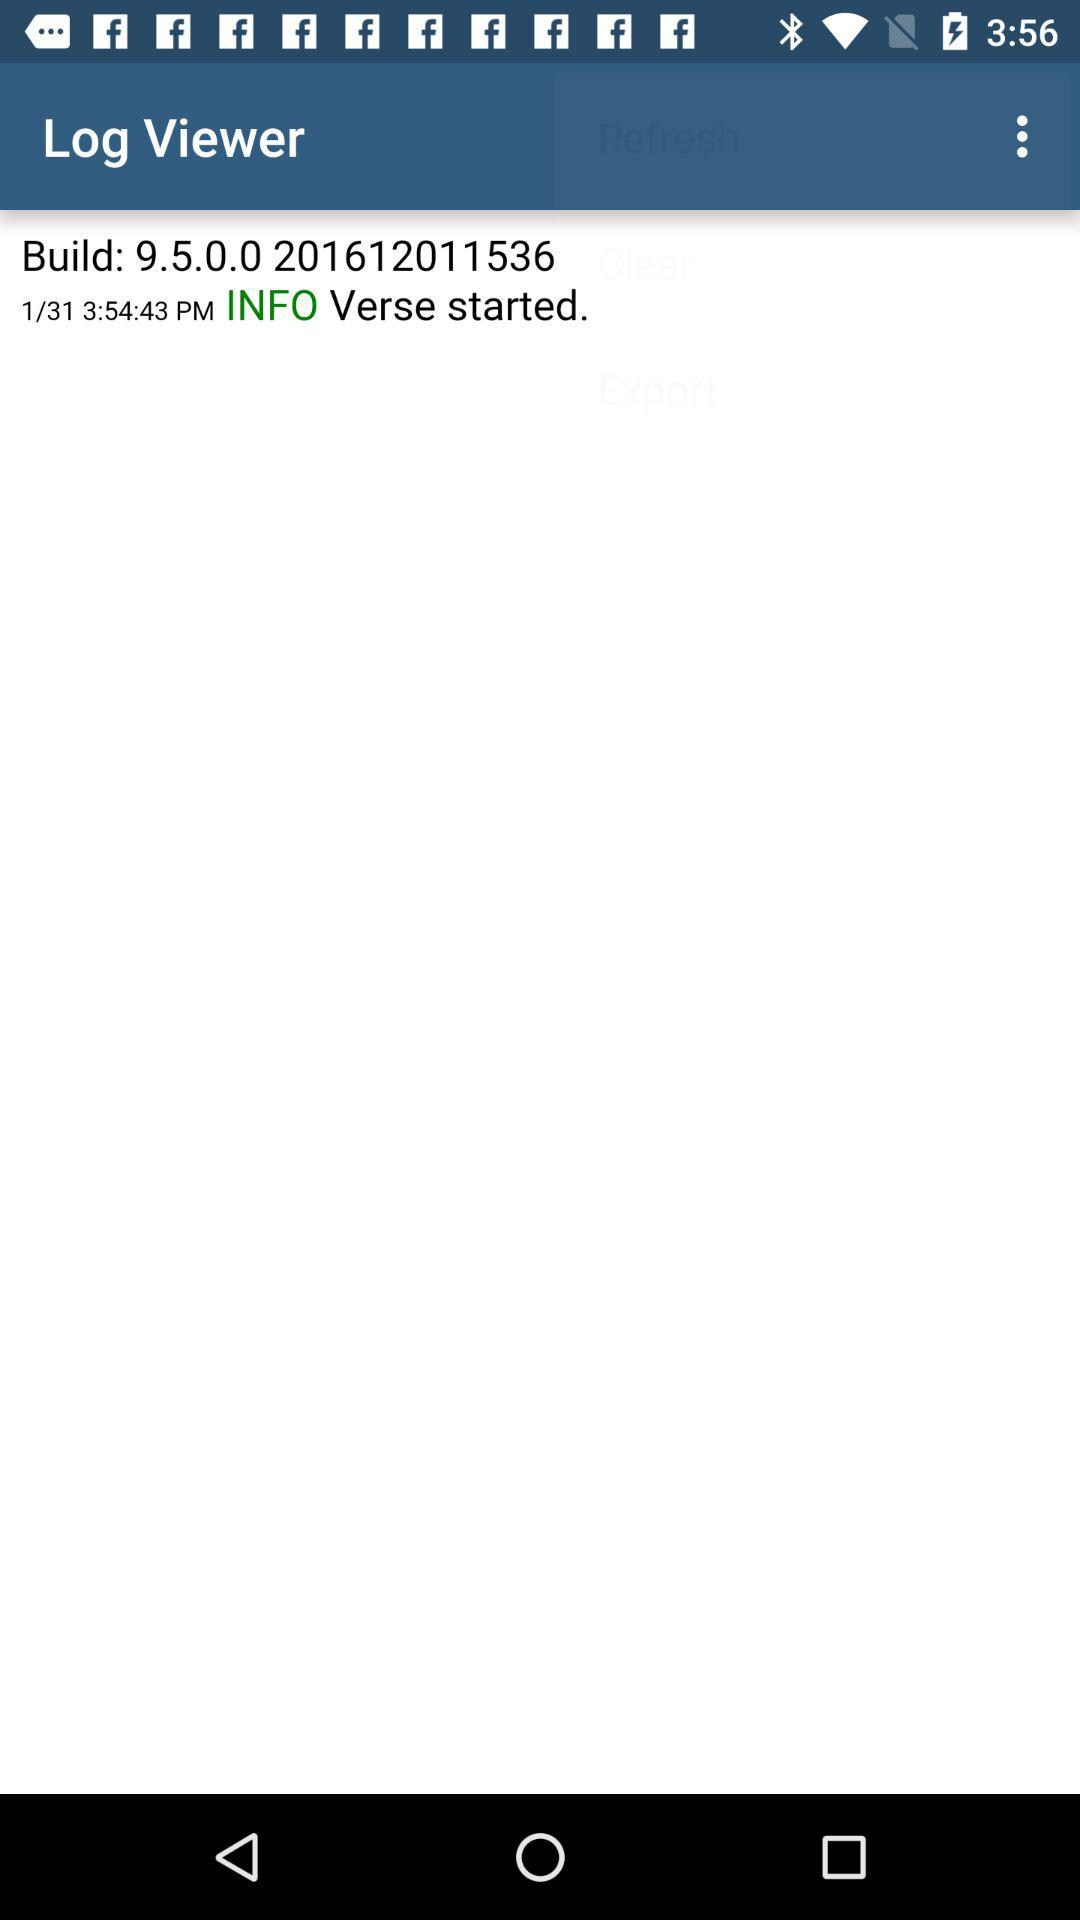What is the app name? The app name is "Log Viewer". 